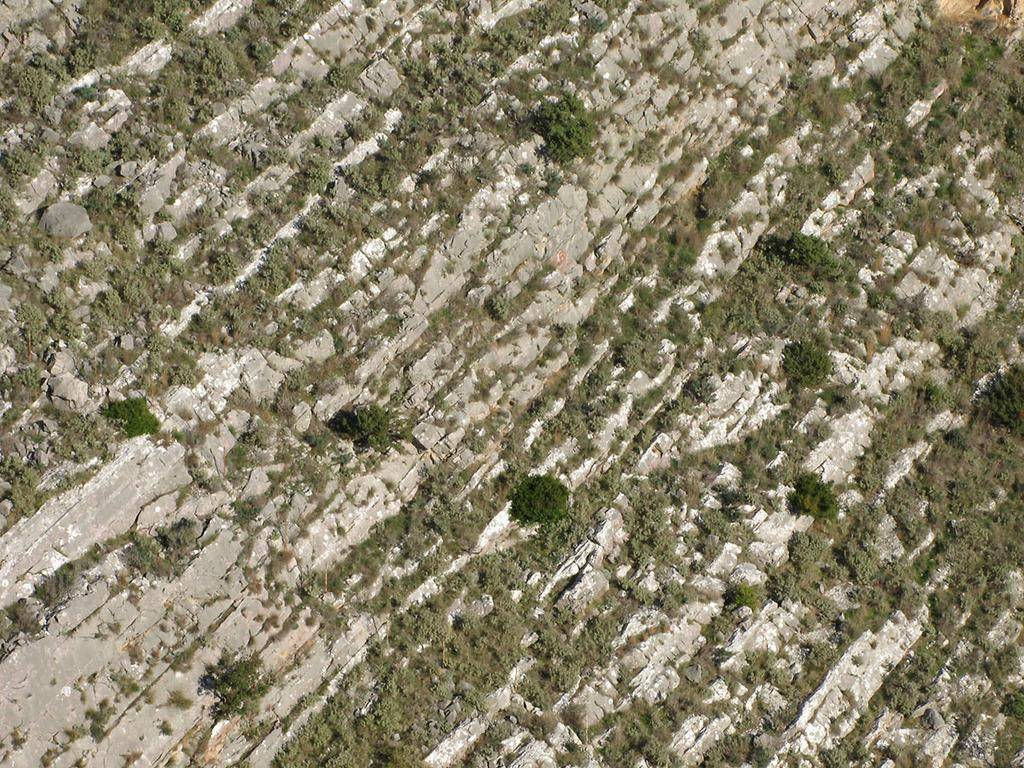What type of surface is visible on the ground in the image? There is grass on the ground in the image. What type of polish is being applied to the wooden train in the image? There is no polish or wooden train present in the image; it only features grass on the ground. 